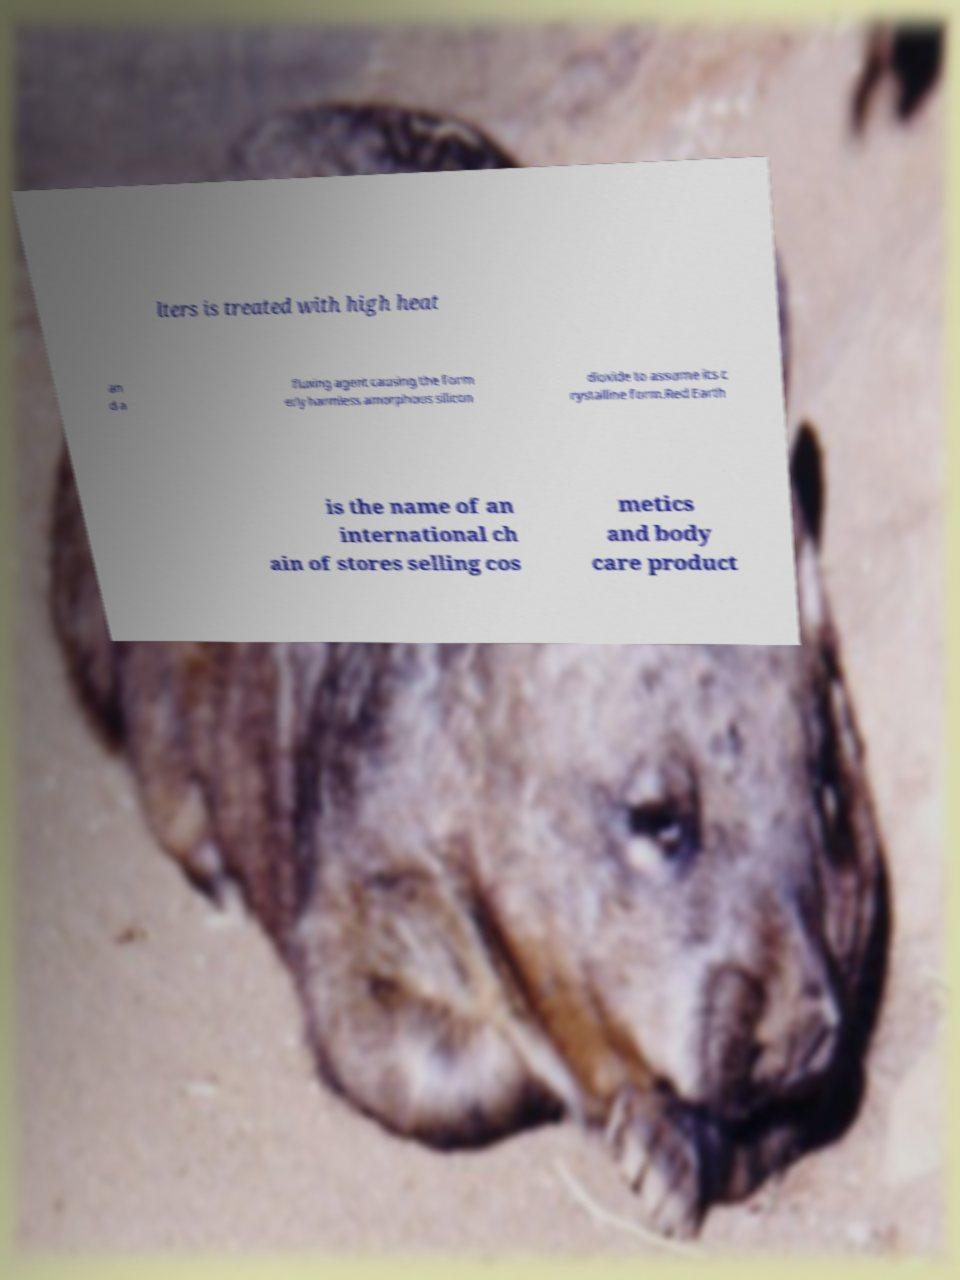Please identify and transcribe the text found in this image. lters is treated with high heat an d a fluxing agent causing the form erly harmless amorphous silicon dioxide to assume its c rystalline form.Red Earth is the name of an international ch ain of stores selling cos metics and body care product 